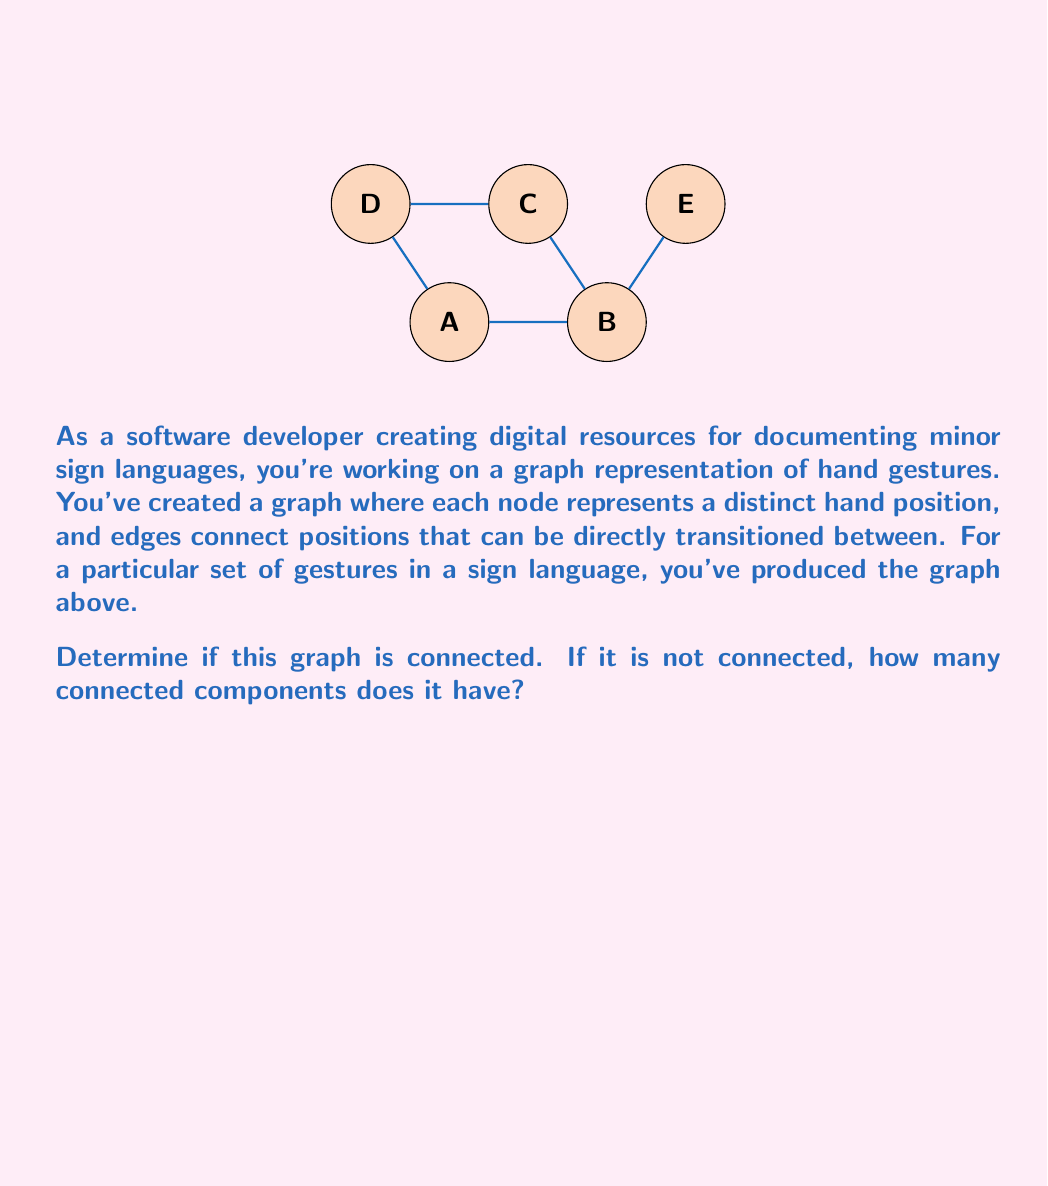Provide a solution to this math problem. To determine if a graph is connected and count its connected components, we need to check if there's a path between every pair of vertices. Let's approach this step-by-step:

1) First, let's check if we can reach all vertices starting from vertex A:
   - We can go A → B → C → D, forming a cycle.
   - We can also reach E through B → E.

2) From this, we can see that there is a path from A to every other vertex in the graph.

3) Since we can reach all vertices from A, and the property of connectedness is symmetric (if A can reach B, B can reach A), this means that there is a path between any two vertices in the graph.

4) The definition of a connected graph is that there exists a path between any two vertices in the graph.

5) Therefore, this graph is connected.

6) Since the graph is connected, it consists of only one connected component.

In terms of topology, a connected graph represents a single continuous "piece" or component. This connectedness in the context of sign language gestures suggests that all represented hand positions can be reached from any other position through a series of allowed transitions.
Answer: The graph is connected; 1 connected component. 